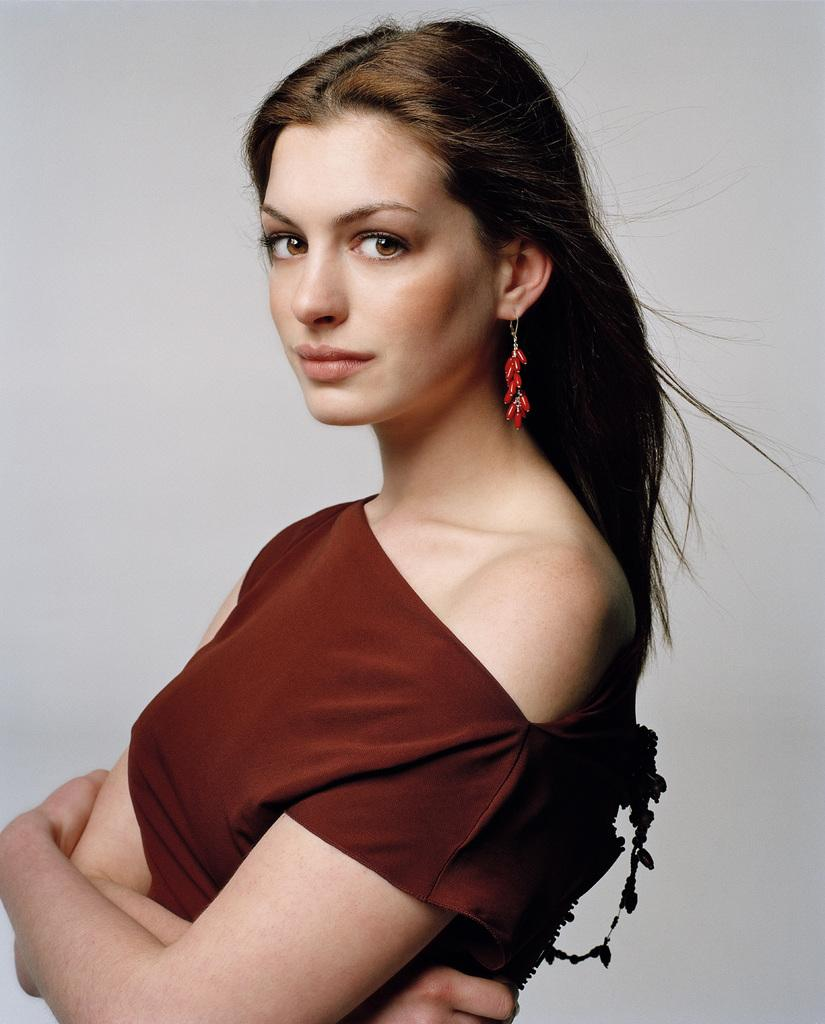What is the main subject of the image? There is a woman standing in the image. What can be observed about the background of the image? The background of the image is white. Where is the pail located in the image? There is no pail present in the image. What type of bee can be seen buzzing around the woman in the image? There are no bees present in the image. 